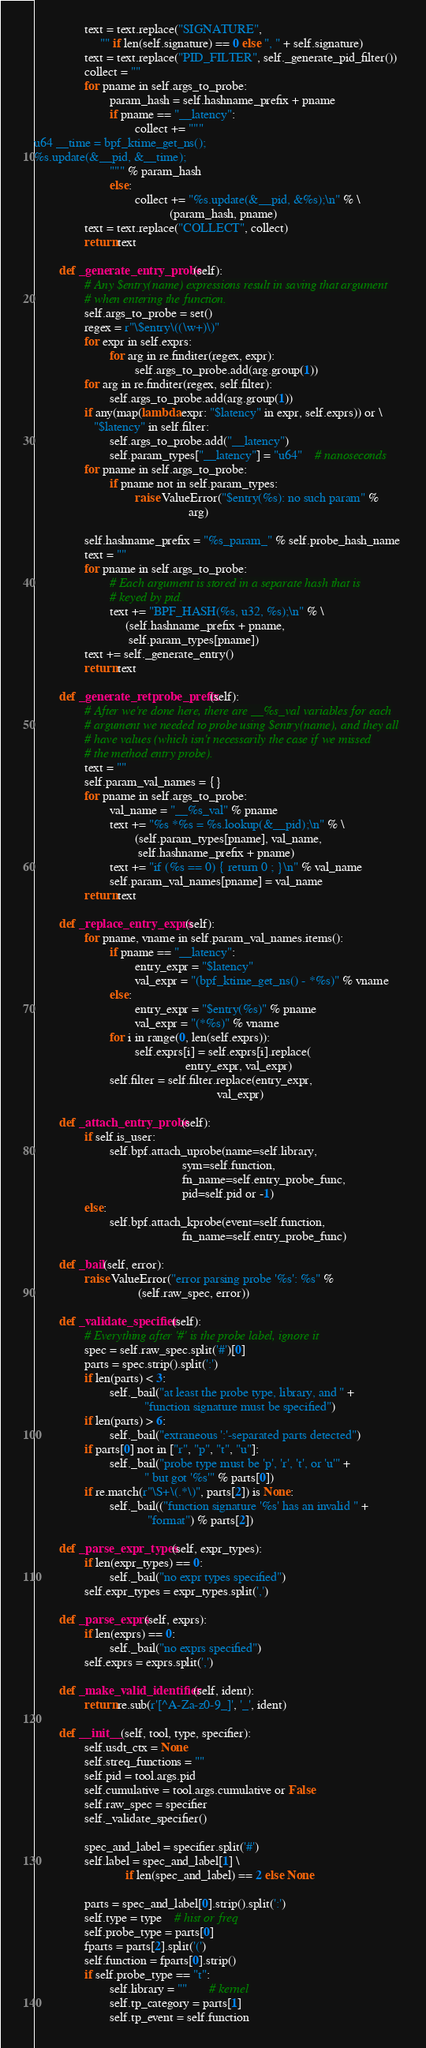Convert code to text. <code><loc_0><loc_0><loc_500><loc_500><_Python_>                text = text.replace("SIGNATURE",
                     "" if len(self.signature) == 0 else ", " + self.signature)
                text = text.replace("PID_FILTER", self._generate_pid_filter())
                collect = ""
                for pname in self.args_to_probe:
                        param_hash = self.hashname_prefix + pname
                        if pname == "__latency":
                                collect += """
u64 __time = bpf_ktime_get_ns();
%s.update(&__pid, &__time);
                        """ % param_hash
                        else:
                                collect += "%s.update(&__pid, &%s);\n" % \
                                           (param_hash, pname)
                text = text.replace("COLLECT", collect)
                return text

        def _generate_entry_probe(self):
                # Any $entry(name) expressions result in saving that argument
                # when entering the function.
                self.args_to_probe = set()
                regex = r"\$entry\((\w+)\)"
                for expr in self.exprs:
                        for arg in re.finditer(regex, expr):
                                self.args_to_probe.add(arg.group(1))
                for arg in re.finditer(regex, self.filter):
                        self.args_to_probe.add(arg.group(1))
                if any(map(lambda expr: "$latency" in expr, self.exprs)) or \
                   "$latency" in self.filter:
                        self.args_to_probe.add("__latency")
                        self.param_types["__latency"] = "u64"    # nanoseconds
                for pname in self.args_to_probe:
                        if pname not in self.param_types:
                                raise ValueError("$entry(%s): no such param" %
                                                 arg)

                self.hashname_prefix = "%s_param_" % self.probe_hash_name
                text = ""
                for pname in self.args_to_probe:
                        # Each argument is stored in a separate hash that is
                        # keyed by pid.
                        text += "BPF_HASH(%s, u32, %s);\n" % \
                             (self.hashname_prefix + pname,
                              self.param_types[pname])
                text += self._generate_entry()
                return text

        def _generate_retprobe_prefix(self):
                # After we're done here, there are __%s_val variables for each
                # argument we needed to probe using $entry(name), and they all
                # have values (which isn't necessarily the case if we missed
                # the method entry probe).
                text = ""
                self.param_val_names = {}
                for pname in self.args_to_probe:
                        val_name = "__%s_val" % pname
                        text += "%s *%s = %s.lookup(&__pid);\n" % \
                                (self.param_types[pname], val_name,
                                 self.hashname_prefix + pname)
                        text += "if (%s == 0) { return 0 ; }\n" % val_name
                        self.param_val_names[pname] = val_name
                return text

        def _replace_entry_exprs(self):
                for pname, vname in self.param_val_names.items():
                        if pname == "__latency":
                                entry_expr = "$latency"
                                val_expr = "(bpf_ktime_get_ns() - *%s)" % vname
                        else:
                                entry_expr = "$entry(%s)" % pname
                                val_expr = "(*%s)" % vname
                        for i in range(0, len(self.exprs)):
                                self.exprs[i] = self.exprs[i].replace(
                                                entry_expr, val_expr)
                        self.filter = self.filter.replace(entry_expr,
                                                          val_expr)

        def _attach_entry_probe(self):
                if self.is_user:
                        self.bpf.attach_uprobe(name=self.library,
                                               sym=self.function,
                                               fn_name=self.entry_probe_func,
                                               pid=self.pid or -1)
                else:
                        self.bpf.attach_kprobe(event=self.function,
                                               fn_name=self.entry_probe_func)

        def _bail(self, error):
                raise ValueError("error parsing probe '%s': %s" %
                                 (self.raw_spec, error))

        def _validate_specifier(self):
                # Everything after '#' is the probe label, ignore it
                spec = self.raw_spec.split('#')[0]
                parts = spec.strip().split(':')
                if len(parts) < 3:
                        self._bail("at least the probe type, library, and " +
                                   "function signature must be specified")
                if len(parts) > 6:
                        self._bail("extraneous ':'-separated parts detected")
                if parts[0] not in ["r", "p", "t", "u"]:
                        self._bail("probe type must be 'p', 'r', 't', or 'u'" +
                                   " but got '%s'" % parts[0])
                if re.match(r"\S+\(.*\)", parts[2]) is None:
                        self._bail(("function signature '%s' has an invalid " +
                                    "format") % parts[2])

        def _parse_expr_types(self, expr_types):
                if len(expr_types) == 0:
                        self._bail("no expr types specified")
                self.expr_types = expr_types.split(',')

        def _parse_exprs(self, exprs):
                if len(exprs) == 0:
                        self._bail("no exprs specified")
                self.exprs = exprs.split(',')

        def _make_valid_identifier(self, ident):
                return re.sub(r'[^A-Za-z0-9_]', '_', ident)

        def __init__(self, tool, type, specifier):
                self.usdt_ctx = None
                self.streq_functions = ""
                self.pid = tool.args.pid
                self.cumulative = tool.args.cumulative or False
                self.raw_spec = specifier
                self._validate_specifier()

                spec_and_label = specifier.split('#')
                self.label = spec_and_label[1] \
                             if len(spec_and_label) == 2 else None

                parts = spec_and_label[0].strip().split(':')
                self.type = type    # hist or freq
                self.probe_type = parts[0]
                fparts = parts[2].split('(')
                self.function = fparts[0].strip()
                if self.probe_type == "t":
                        self.library = ""       # kernel
                        self.tp_category = parts[1]
                        self.tp_event = self.function</code> 